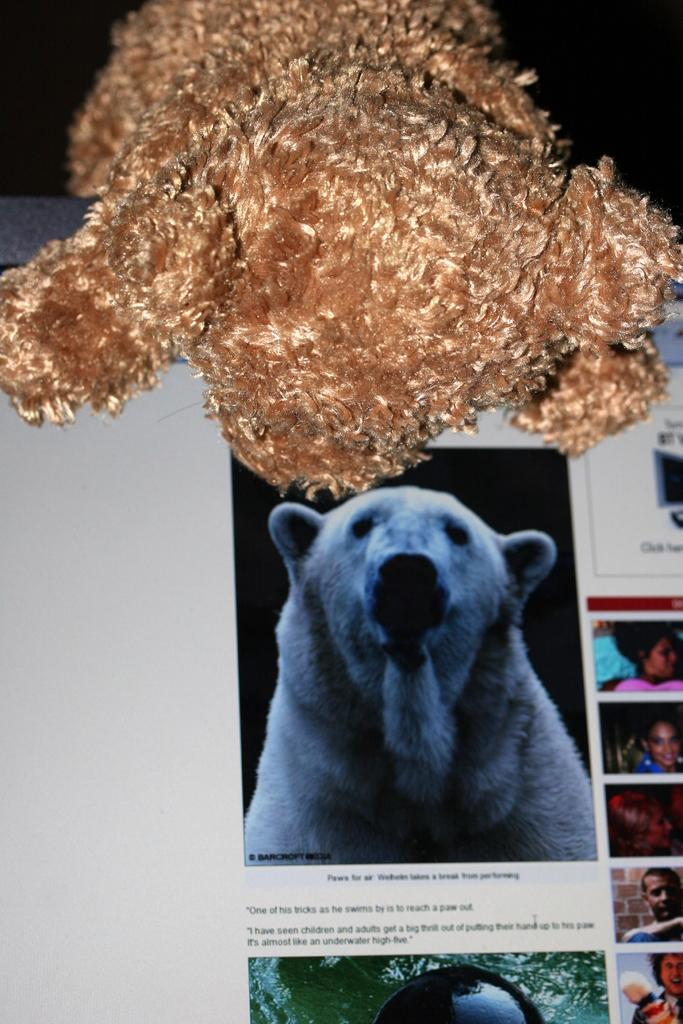What is the main object in the image? There is a screen in the image. What can be seen on the screen? An animal and people are visible on the screen. Are there any other objects in the image besides the screen? Yes, there is a brown teddy bear in the image. What type of jewel is the teddy bear wearing in the image? There is no jewel present on the teddy bear in the image. What is the current status of the animal on the screen? The current status of the animal on the screen cannot be determined from the image. 